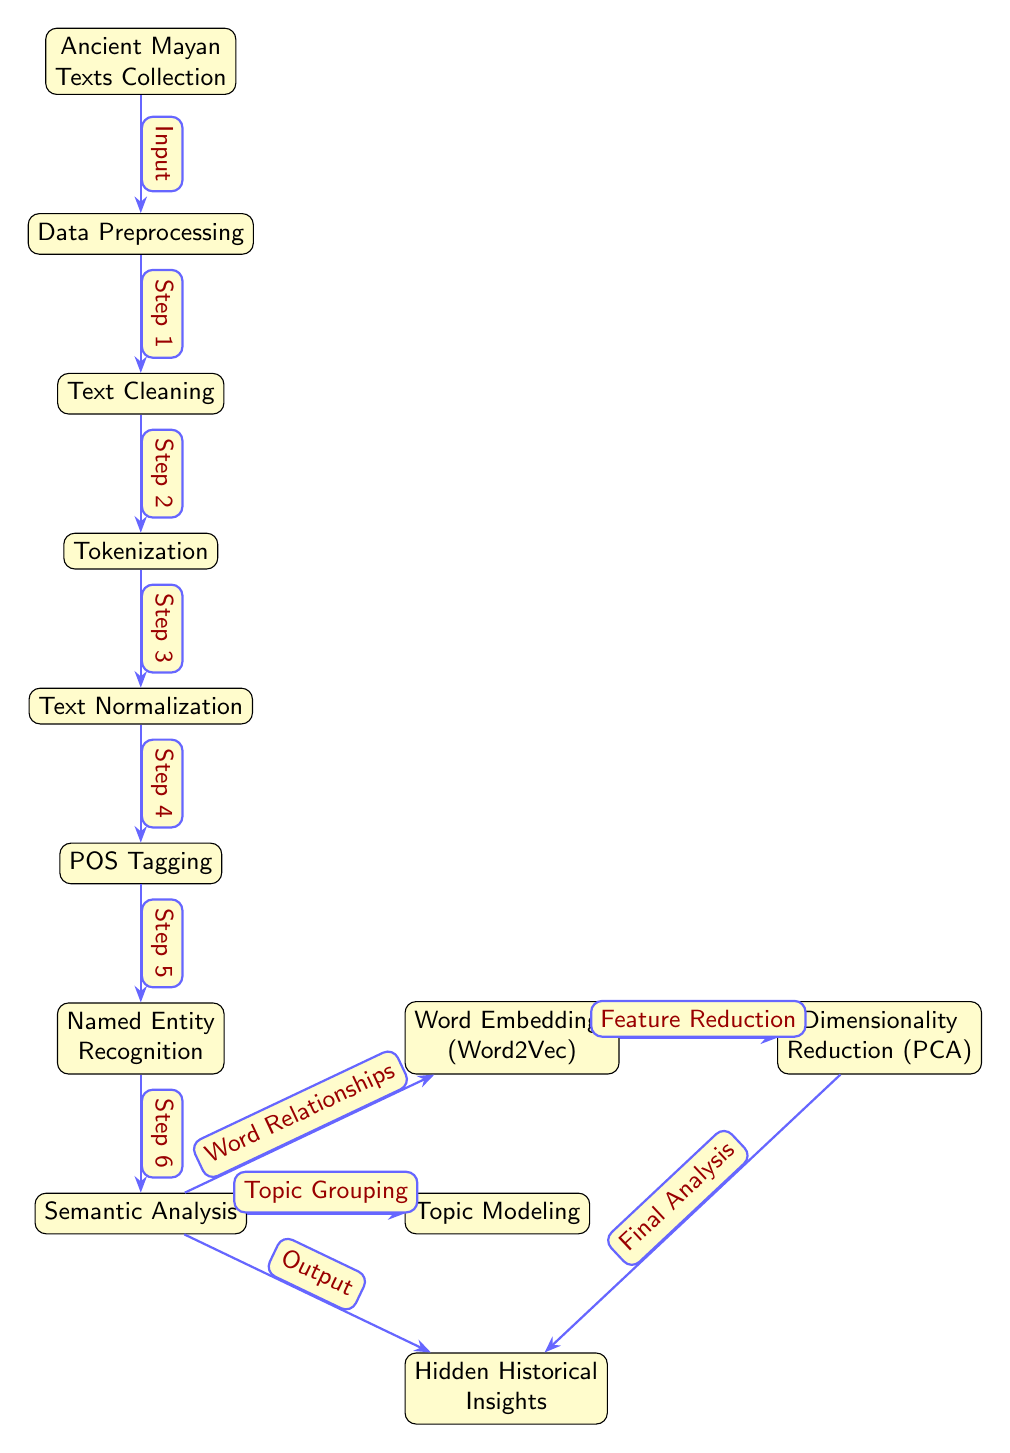What is the first node in the diagram? The first node in the diagram is labeled "Ancient Mayan Texts Collection."
Answer: Ancient Mayan Texts Collection How many processing steps are there in the diagram? There are six processing steps listed between the input and the output: Data Preprocessing, Text Cleaning, Tokenization, Text Normalization, POS Tagging, and Named Entity Recognition.
Answer: 6 What is the output of the diagram? The output of the diagram is "Hidden Historical Insights," which results from the final processing step after semantic analysis.
Answer: Hidden Historical Insights Which node precedes Topic Modeling? The node that precedes "Topic Modeling" is "Semantic Analysis," as the arrows indicate that Topic Modeling branches off directly from Semantic Analysis.
Answer: Semantic Analysis What is the relationship between Word Embeddings and Dimensionality Reduction? "Word Embeddings" is the source node from which "Dimensionality Reduction" is connected, indicating that Dimensionality Reduction follows the output of Word Embeddings.
Answer: Dimensionality Reduction How many edges are connected to the Semantic Analysis node? The "Semantic Analysis" node has three edges connected to it: one going to "Hidden Historical Insights," one to "Topic Modeling," and one to "Word Embeddings."
Answer: 3 What step comes after Named Entity Recognition? The step that comes immediately after "Named Entity Recognition" is "Semantic Analysis," indicating a sequential flow in the diagram.
Answer: Semantic Analysis What does the edge label "Final Analysis" refer to? The edge label "Final Analysis" signifies the final step leading from "Dimensionality Reduction" to "Hidden Historical Insights," highlighting the concluding operation of the analysis.
Answer: Final Analysis Which node validates the relationships between words? The node that validates the relationships between words is "Word Embeddings (Word2Vec)," as it specifically deals with understanding word relationships.
Answer: Word Embeddings (Word2Vec) 